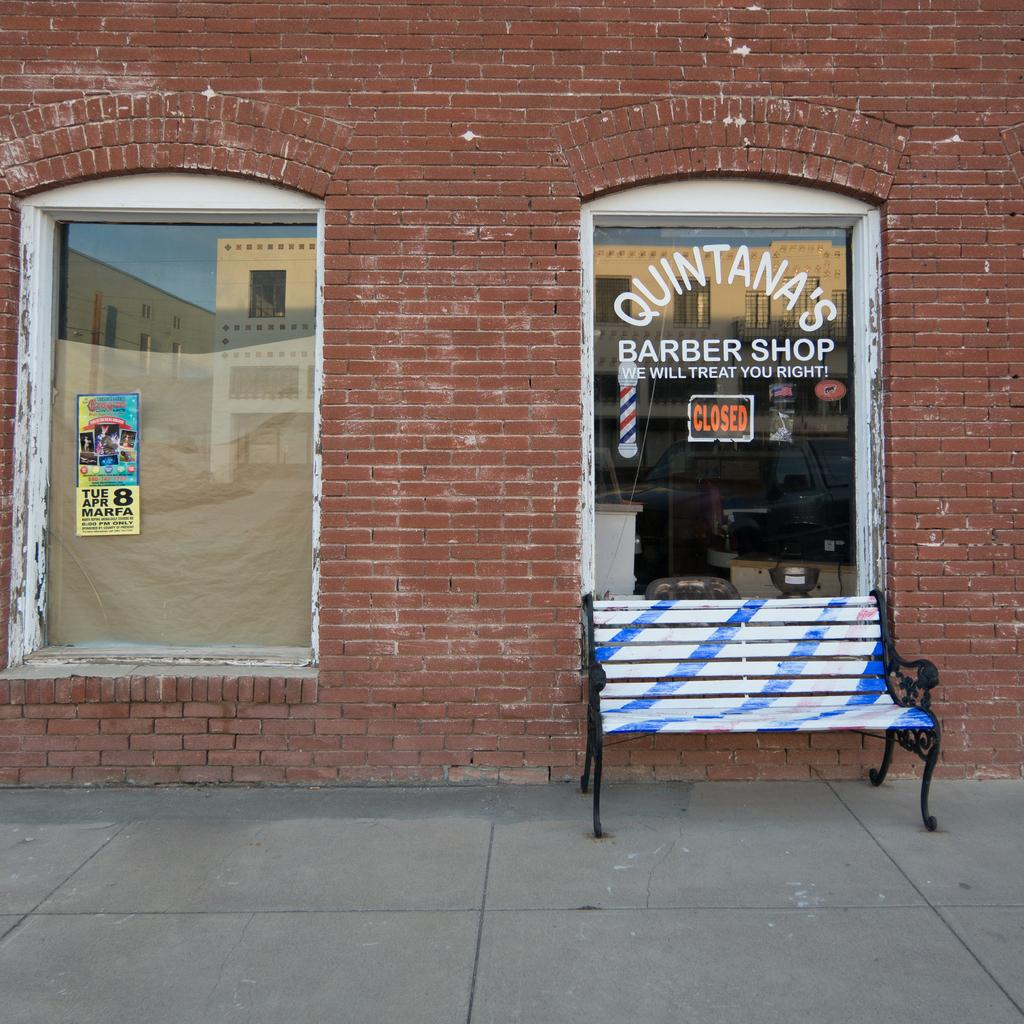What type of structure is visible in the image? There is a building in the image. What type of seating is present in the image? There is a bench in the image. What surface can be seen beneath the bench? There is a floor in the image. What type of expansion is taking place in the image? There is no expansion visible in the image. Is there a jail present in the image? There is no jail present in the image. 